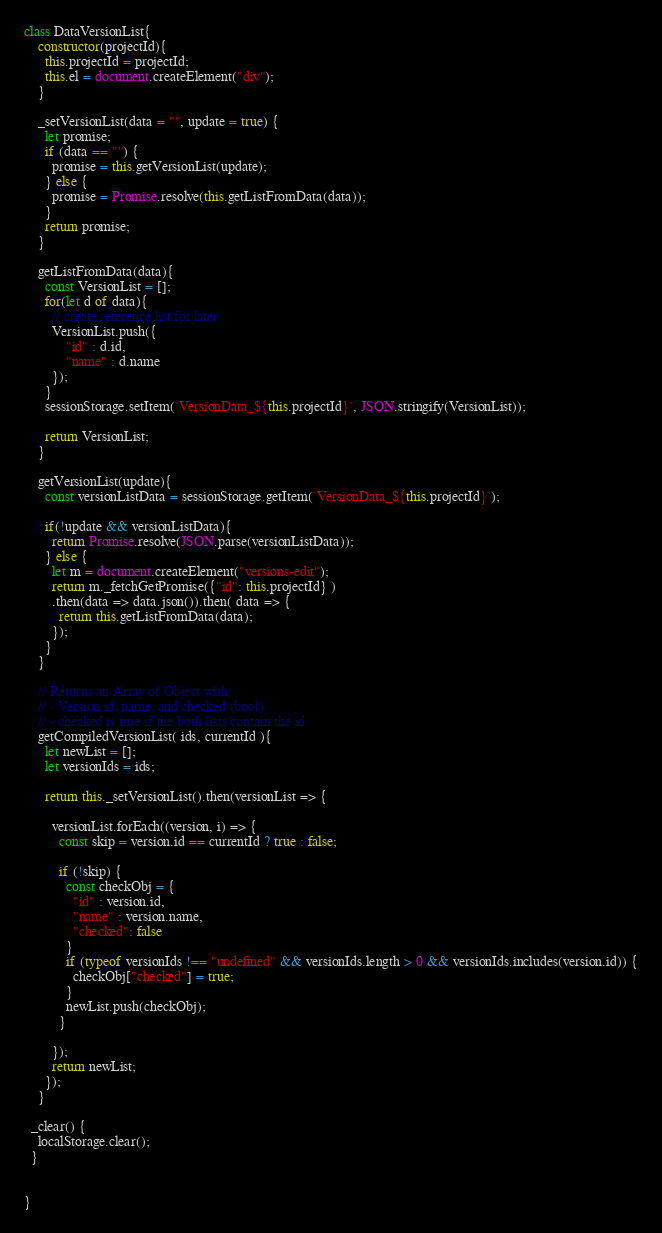<code> <loc_0><loc_0><loc_500><loc_500><_JavaScript_>class DataVersionList{
    constructor(projectId){
      this.projectId = projectId;
      this.el = document.createElement("div");
    }

    _setVersionList(data = "", update = true) {
      let promise;
      if (data == "") {
        promise = this.getVersionList(update);
      } else {
        promise = Promise.resolve(this.getListFromData(data));
      }
      return promise;
    }

    getListFromData(data){
      const VersionList = [];
      for(let d of data){
        // create reference list for later
        VersionList.push({
            "id" : d.id,
            "name" : d.name
        });
      }
      sessionStorage.setItem(`VersionData_${this.projectId}`, JSON.stringify(VersionList));

      return VersionList;
    }

    getVersionList(update){     
      const versionListData = sessionStorage.getItem(`VersionData_${this.projectId}`);

      if(!update && versionListData){
        return Promise.resolve(JSON.parse(versionListData));      
      } else {
        let m = document.createElement("versions-edit");
        return m._fetchGetPromise({"id": this.projectId} )
        .then(data => data.json()).then( data => {
          return this.getListFromData(data);
        });
      }      
    }

    // Returns an Array of Object with:
    // - Version id, name, and checked (bool)
    // - checked is true if the both lists contain the id
    getCompiledVersionList( ids, currentId ){
      let newList = [];
      let versionIds = ids;

      return this._setVersionList().then(versionList => {

        versionList.forEach((version, i) => {
          const skip = version.id == currentId ? true : false;

          if (!skip) {
            const checkObj = {
              "id" : version.id,
              "name" : version.name,
              "checked": false
            }
            if (typeof versionIds !== "undefined" && versionIds.length > 0 && versionIds.includes(version.id)) {
              checkObj["checked"] = true;
            }
            newList.push(checkObj);
          }

        });
        return newList;
      });
    }
  
  _clear() {
    localStorage.clear();
  }


}
</code> 